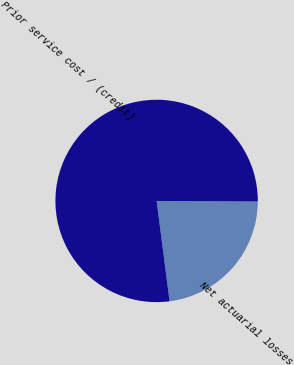Convert chart to OTSL. <chart><loc_0><loc_0><loc_500><loc_500><pie_chart><fcel>Net actuarial losses<fcel>Prior service cost / (credit)<nl><fcel>22.86%<fcel>77.14%<nl></chart> 